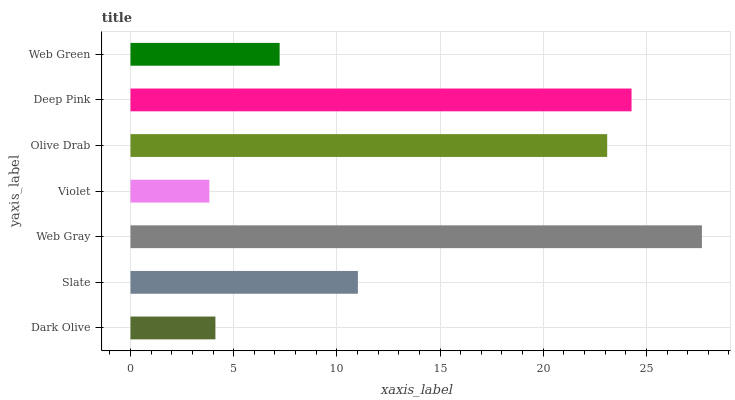Is Violet the minimum?
Answer yes or no. Yes. Is Web Gray the maximum?
Answer yes or no. Yes. Is Slate the minimum?
Answer yes or no. No. Is Slate the maximum?
Answer yes or no. No. Is Slate greater than Dark Olive?
Answer yes or no. Yes. Is Dark Olive less than Slate?
Answer yes or no. Yes. Is Dark Olive greater than Slate?
Answer yes or no. No. Is Slate less than Dark Olive?
Answer yes or no. No. Is Slate the high median?
Answer yes or no. Yes. Is Slate the low median?
Answer yes or no. Yes. Is Deep Pink the high median?
Answer yes or no. No. Is Violet the low median?
Answer yes or no. No. 